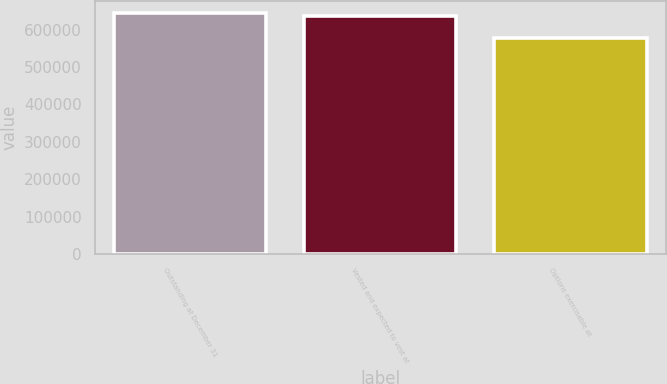Convert chart to OTSL. <chart><loc_0><loc_0><loc_500><loc_500><bar_chart><fcel>Outstanding at December 31<fcel>Vested and expected to vest at<fcel>Options exercisable at<nl><fcel>644148<fcel>637311<fcel>576802<nl></chart> 